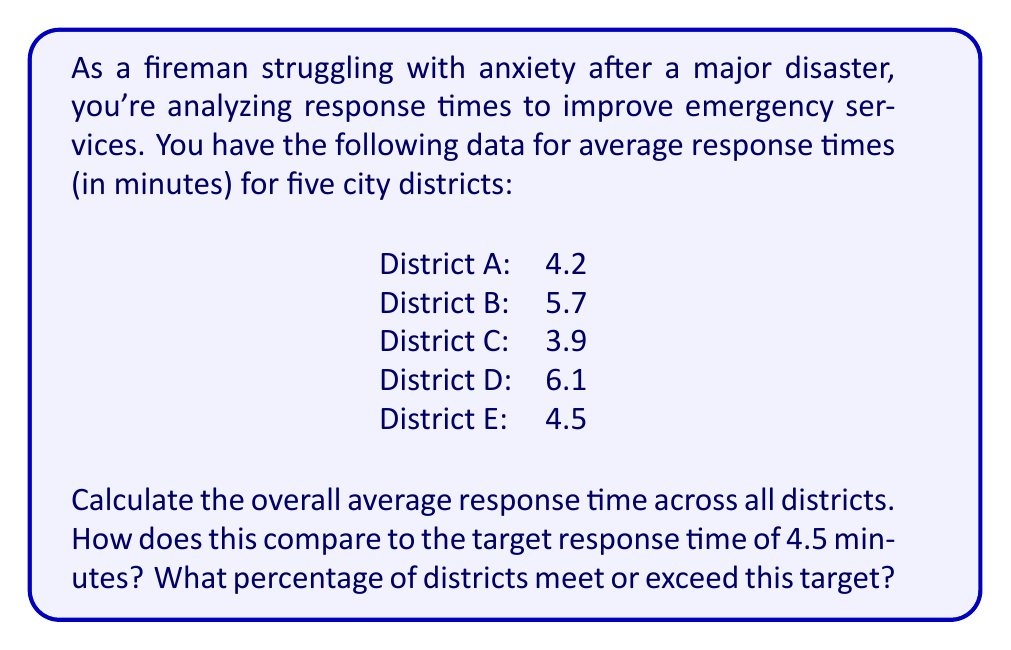Teach me how to tackle this problem. To solve this problem, we'll follow these steps:

1. Calculate the overall average response time:
   $$\text{Average} = \frac{\sum \text{Response Times}}{\text{Number of Districts}}$$
   
   $$\text{Average} = \frac{4.2 + 5.7 + 3.9 + 6.1 + 4.5}{5} = \frac{24.4}{5} = 4.88 \text{ minutes}$$

2. Compare to the target response time:
   The overall average (4.88 minutes) is higher than the target (4.5 minutes).

3. Calculate the percentage of districts meeting or exceeding the target:
   Districts A, C, and E meet or exceed the target.
   $$\text{Percentage} = \frac{\text{Number of districts meeting target}}{\text{Total number of districts}} \times 100\%$$
   $$\text{Percentage} = \frac{3}{5} \times 100\% = 60\%$$
Answer: The overall average response time is 4.88 minutes. This is 0.38 minutes slower than the target of 4.5 minutes. 60% of the districts meet or exceed the target response time. 